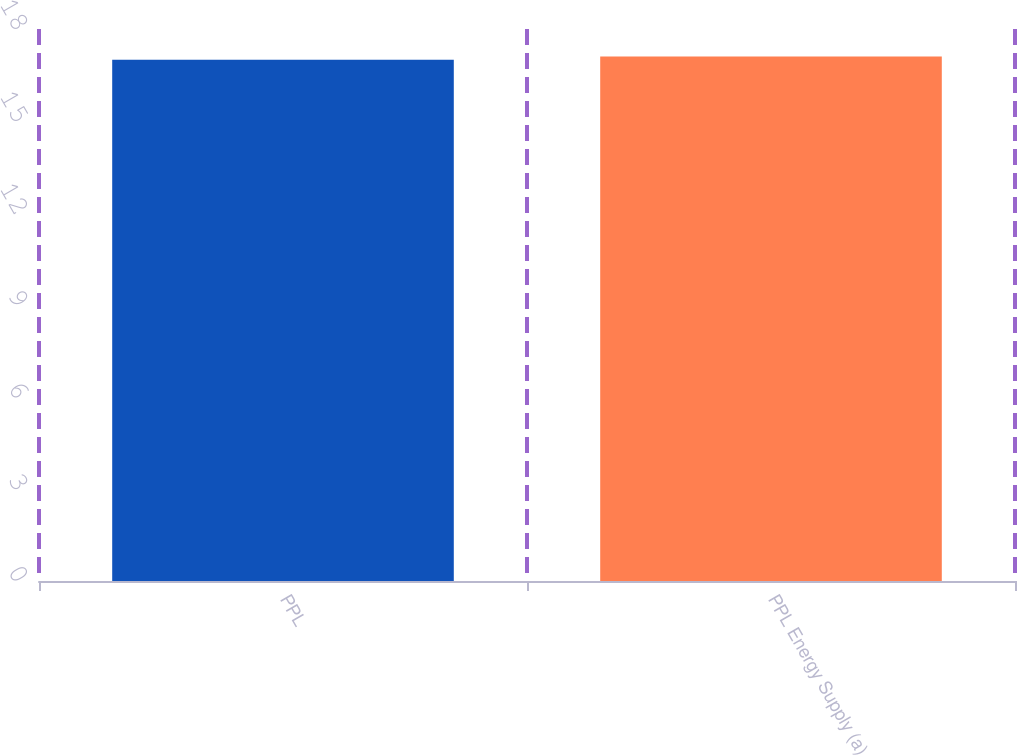Convert chart to OTSL. <chart><loc_0><loc_0><loc_500><loc_500><bar_chart><fcel>PPL<fcel>PPL Energy Supply (a)<nl><fcel>17<fcel>17.1<nl></chart> 